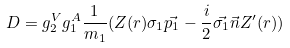<formula> <loc_0><loc_0><loc_500><loc_500>D = g ^ { V } _ { 2 } g ^ { A } _ { 1 } \frac { 1 } { m _ { 1 } } ( Z ( r ) \sigma _ { 1 } \vec { p _ { 1 } } - \frac { i } { 2 } \vec { \sigma _ { 1 } } \vec { n } Z ^ { \prime } ( r ) )</formula> 